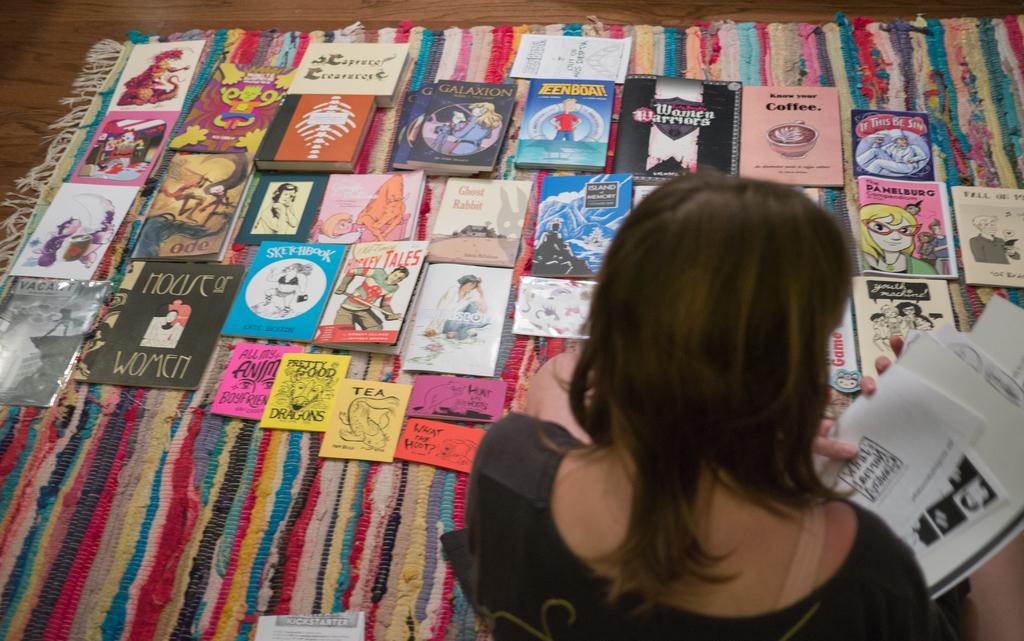Can you describe this image briefly? In this image I can see a woman holding few papers in her hands. I can see few books on the carpet. 